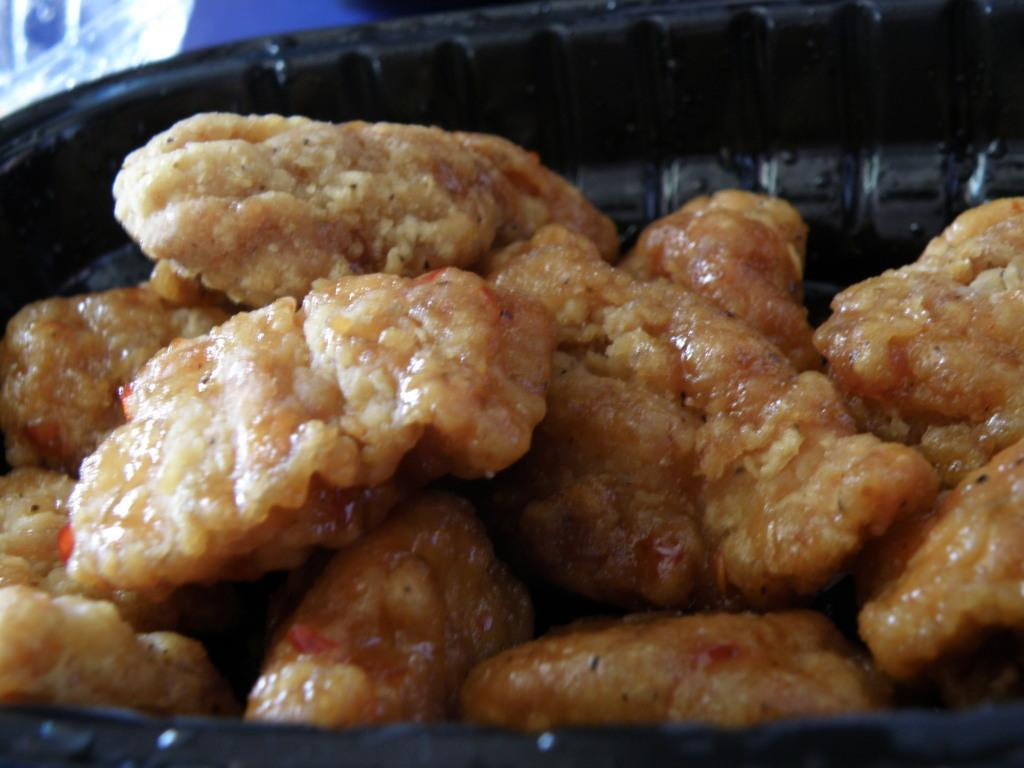What is present in the image? There is a bowl in the image. What is inside the bowl? There is food in the bowl. How many legs does the sock have in the image? There is no sock present in the image. 